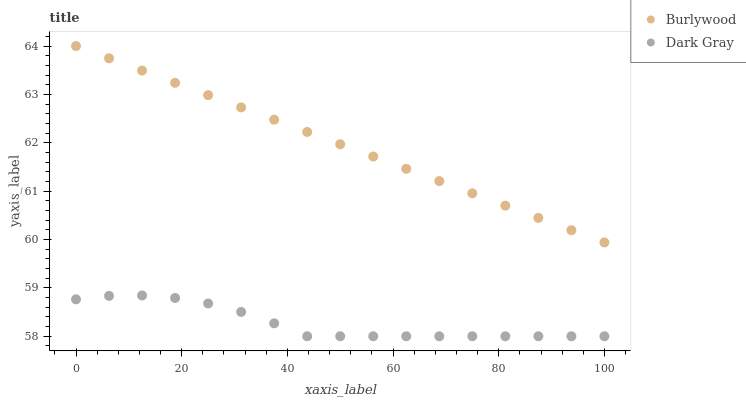Does Dark Gray have the minimum area under the curve?
Answer yes or no. Yes. Does Burlywood have the maximum area under the curve?
Answer yes or no. Yes. Does Dark Gray have the maximum area under the curve?
Answer yes or no. No. Is Burlywood the smoothest?
Answer yes or no. Yes. Is Dark Gray the roughest?
Answer yes or no. Yes. Is Dark Gray the smoothest?
Answer yes or no. No. Does Dark Gray have the lowest value?
Answer yes or no. Yes. Does Burlywood have the highest value?
Answer yes or no. Yes. Does Dark Gray have the highest value?
Answer yes or no. No. Is Dark Gray less than Burlywood?
Answer yes or no. Yes. Is Burlywood greater than Dark Gray?
Answer yes or no. Yes. Does Dark Gray intersect Burlywood?
Answer yes or no. No. 